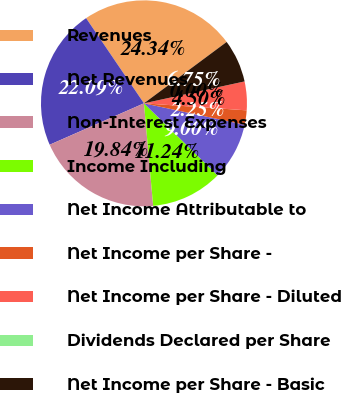Convert chart to OTSL. <chart><loc_0><loc_0><loc_500><loc_500><pie_chart><fcel>Revenues<fcel>Net Revenues<fcel>Non-Interest Expenses<fcel>Income Including<fcel>Net Income Attributable to<fcel>Net Income per Share -<fcel>Net Income per Share - Diluted<fcel>Dividends Declared per Share<fcel>Net Income per Share - Basic<nl><fcel>24.34%<fcel>22.09%<fcel>19.84%<fcel>11.24%<fcel>9.0%<fcel>2.25%<fcel>4.5%<fcel>0.0%<fcel>6.75%<nl></chart> 